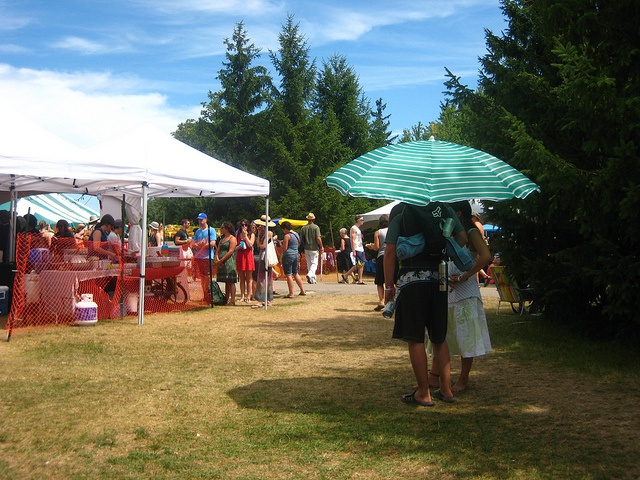Describe the objects in this image and their specific colors. I can see people in lightblue, black, maroon, gray, and teal tones, umbrella in lightblue, teal, turquoise, and ivory tones, people in lightblue, black, maroon, and brown tones, people in lightblue, gray, black, and darkgreen tones, and backpack in lightblue, black, and teal tones in this image. 